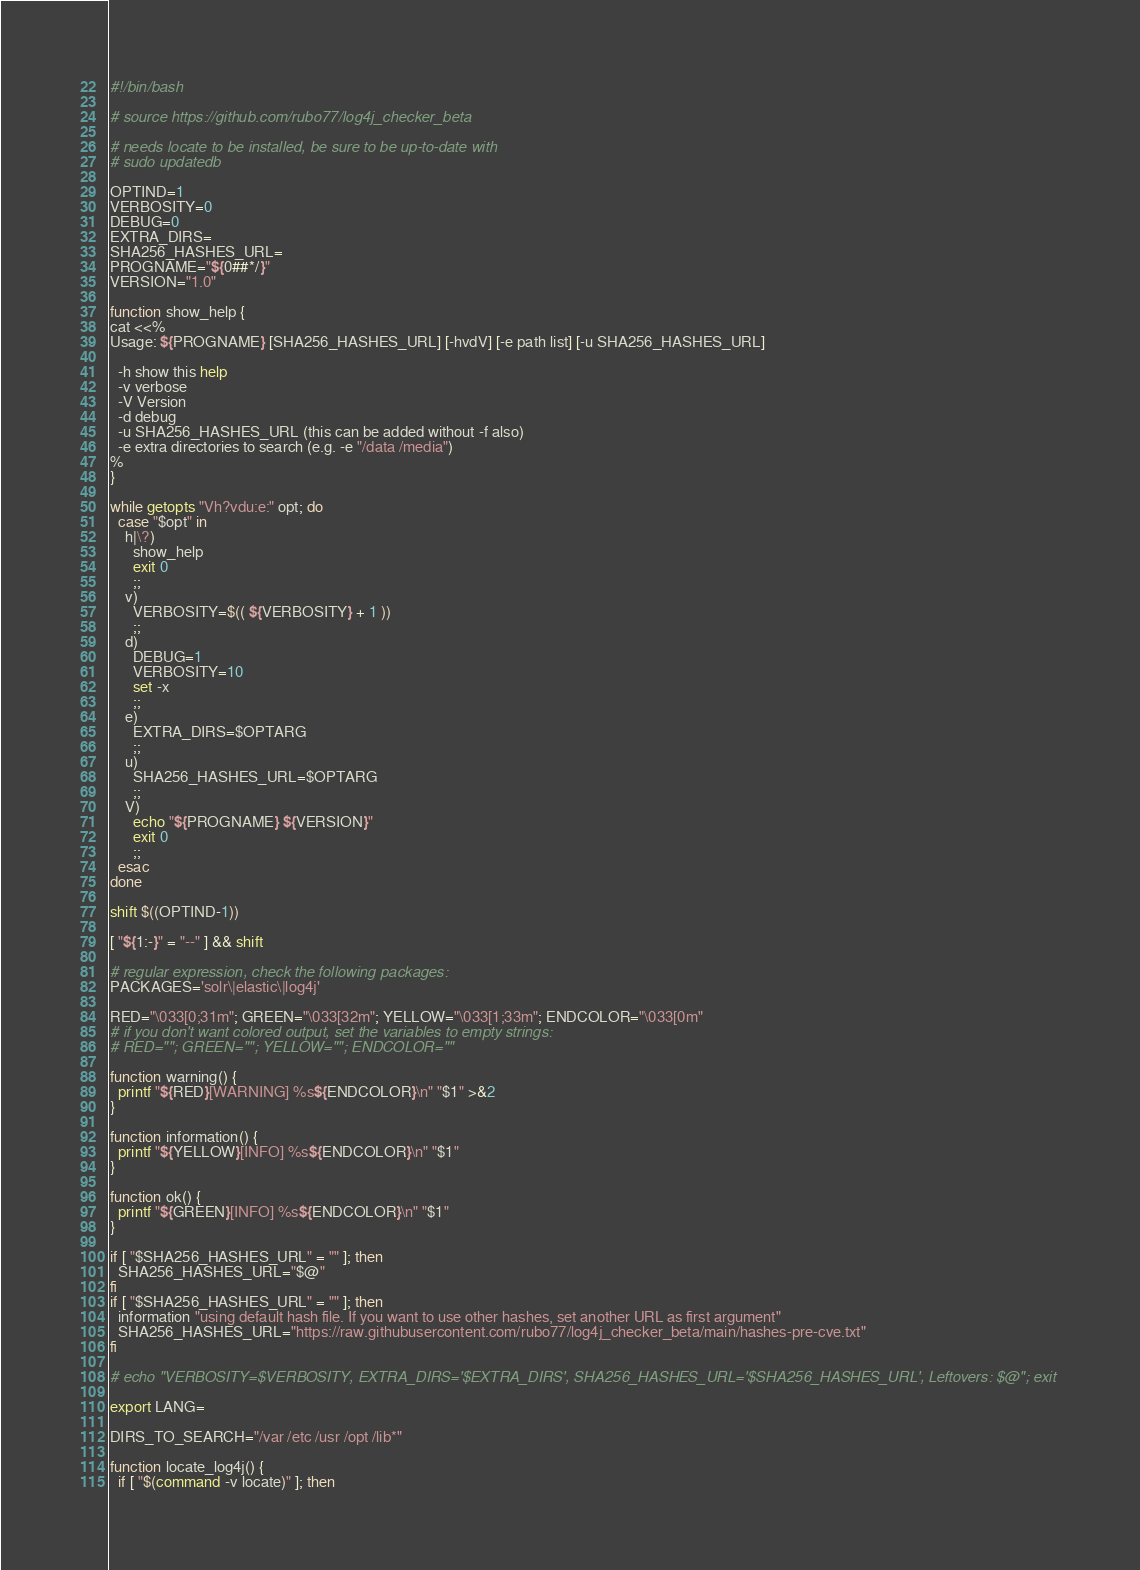Convert code to text. <code><loc_0><loc_0><loc_500><loc_500><_Bash_>#!/bin/bash

# source https://github.com/rubo77/log4j_checker_beta

# needs locate to be installed, be sure to be up-to-date with
# sudo updatedb

OPTIND=1
VERBOSITY=0
DEBUG=0
EXTRA_DIRS=
SHA256_HASHES_URL=
PROGNAME="${0##*/}"
VERSION="1.0"

function show_help {
cat <<%
Usage: ${PROGNAME} [SHA256_HASHES_URL] [-hvdV] [-e path list] [-u SHA256_HASHES_URL]

  -h show this help
  -v verbose
  -V Version
  -d debug
  -u SHA256_HASHES_URL (this can be added without -f also)
  -e extra directories to search (e.g. -e "/data /media")
%
}

while getopts "Vh?vdu:e:" opt; do
  case "$opt" in
    h|\?)
      show_help
      exit 0
      ;;
    v)
      VERBOSITY=$(( ${VERBOSITY} + 1 ))
      ;;
    d)
      DEBUG=1
      VERBOSITY=10
      set -x
      ;;
    e)
      EXTRA_DIRS=$OPTARG
      ;;
    u)
      SHA256_HASHES_URL=$OPTARG
      ;;
    V)
      echo "${PROGNAME} ${VERSION}"
      exit 0
      ;;
  esac
done

shift $((OPTIND-1))

[ "${1:-}" = "--" ] && shift

# regular expression, check the following packages:
PACKAGES='solr\|elastic\|log4j'

RED="\033[0;31m"; GREEN="\033[32m"; YELLOW="\033[1;33m"; ENDCOLOR="\033[0m"
# if you don't want colored output, set the variables to empty strings:
# RED=""; GREEN=""; YELLOW=""; ENDCOLOR=""

function warning() {
  printf "${RED}[WARNING] %s${ENDCOLOR}\n" "$1" >&2
}

function information() {
  printf "${YELLOW}[INFO] %s${ENDCOLOR}\n" "$1"
}

function ok() {
  printf "${GREEN}[INFO] %s${ENDCOLOR}\n" "$1"
}

if [ "$SHA256_HASHES_URL" = "" ]; then
  SHA256_HASHES_URL="$@"
fi
if [ "$SHA256_HASHES_URL" = "" ]; then
  information "using default hash file. If you want to use other hashes, set another URL as first argument"
  SHA256_HASHES_URL="https://raw.githubusercontent.com/rubo77/log4j_checker_beta/main/hashes-pre-cve.txt"
fi

# echo "VERBOSITY=$VERBOSITY, EXTRA_DIRS='$EXTRA_DIRS', SHA256_HASHES_URL='$SHA256_HASHES_URL', Leftovers: $@"; exit

export LANG=

DIRS_TO_SEARCH="/var /etc /usr /opt /lib*"

function locate_log4j() {
  if [ "$(command -v locate)" ]; then</code> 